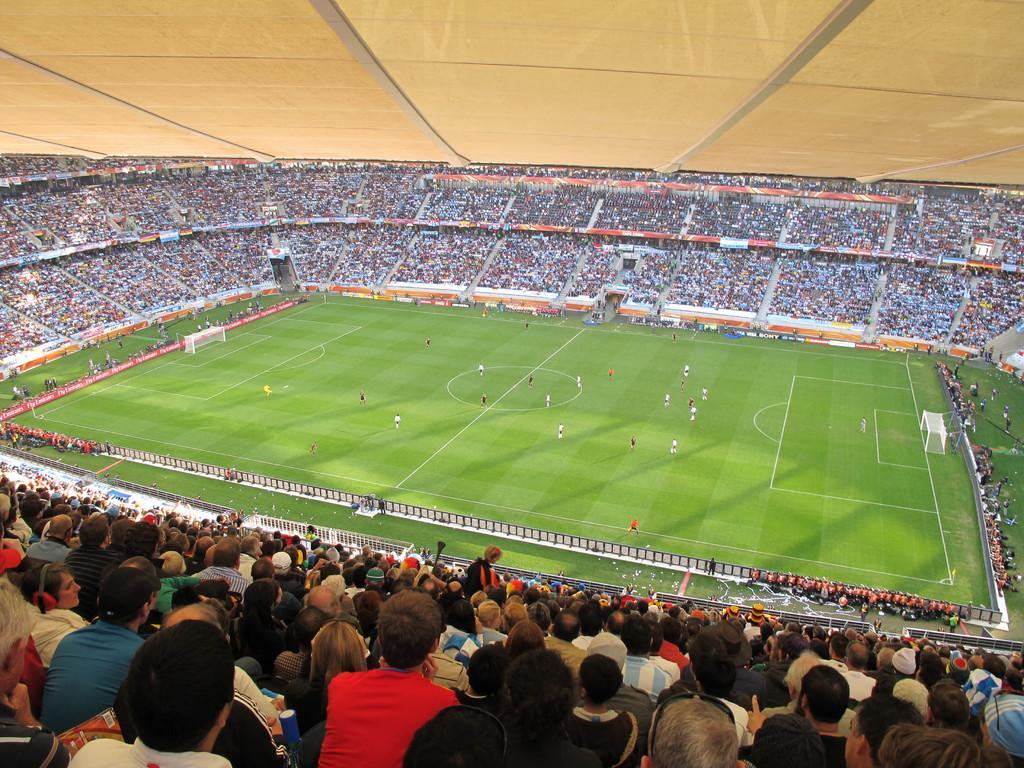In one or two sentences, can you explain what this image depicts? In this image I can see a crowd in the stadium and group of people are playing a football on the ground. This image is taken during a day on the ground. 